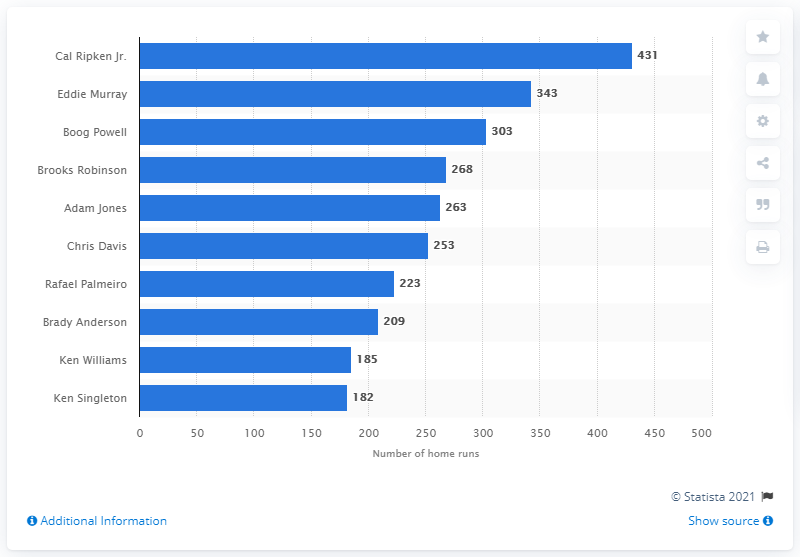Give some essential details in this illustration. As of my knowledge cutoff date of 2021, Cal Ripken Jr. has hit 431 home runs in his illustrious career. 